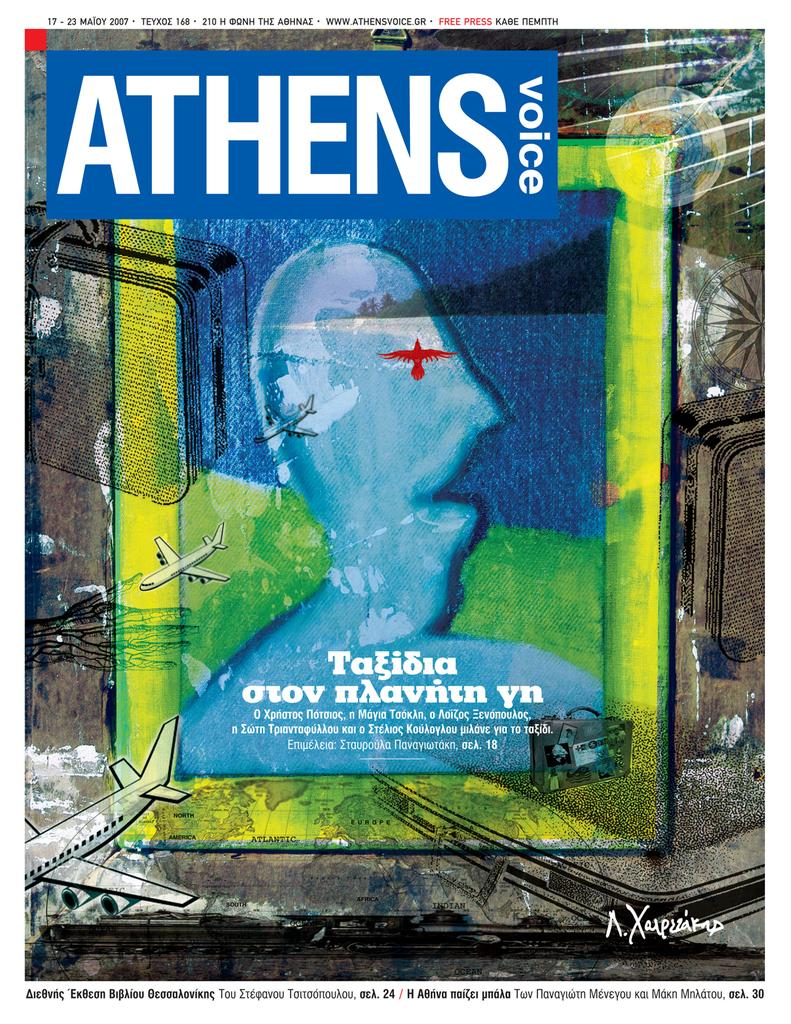<image>
Give a short and clear explanation of the subsequent image. an Athens Voice cover with a artistic man on the front 